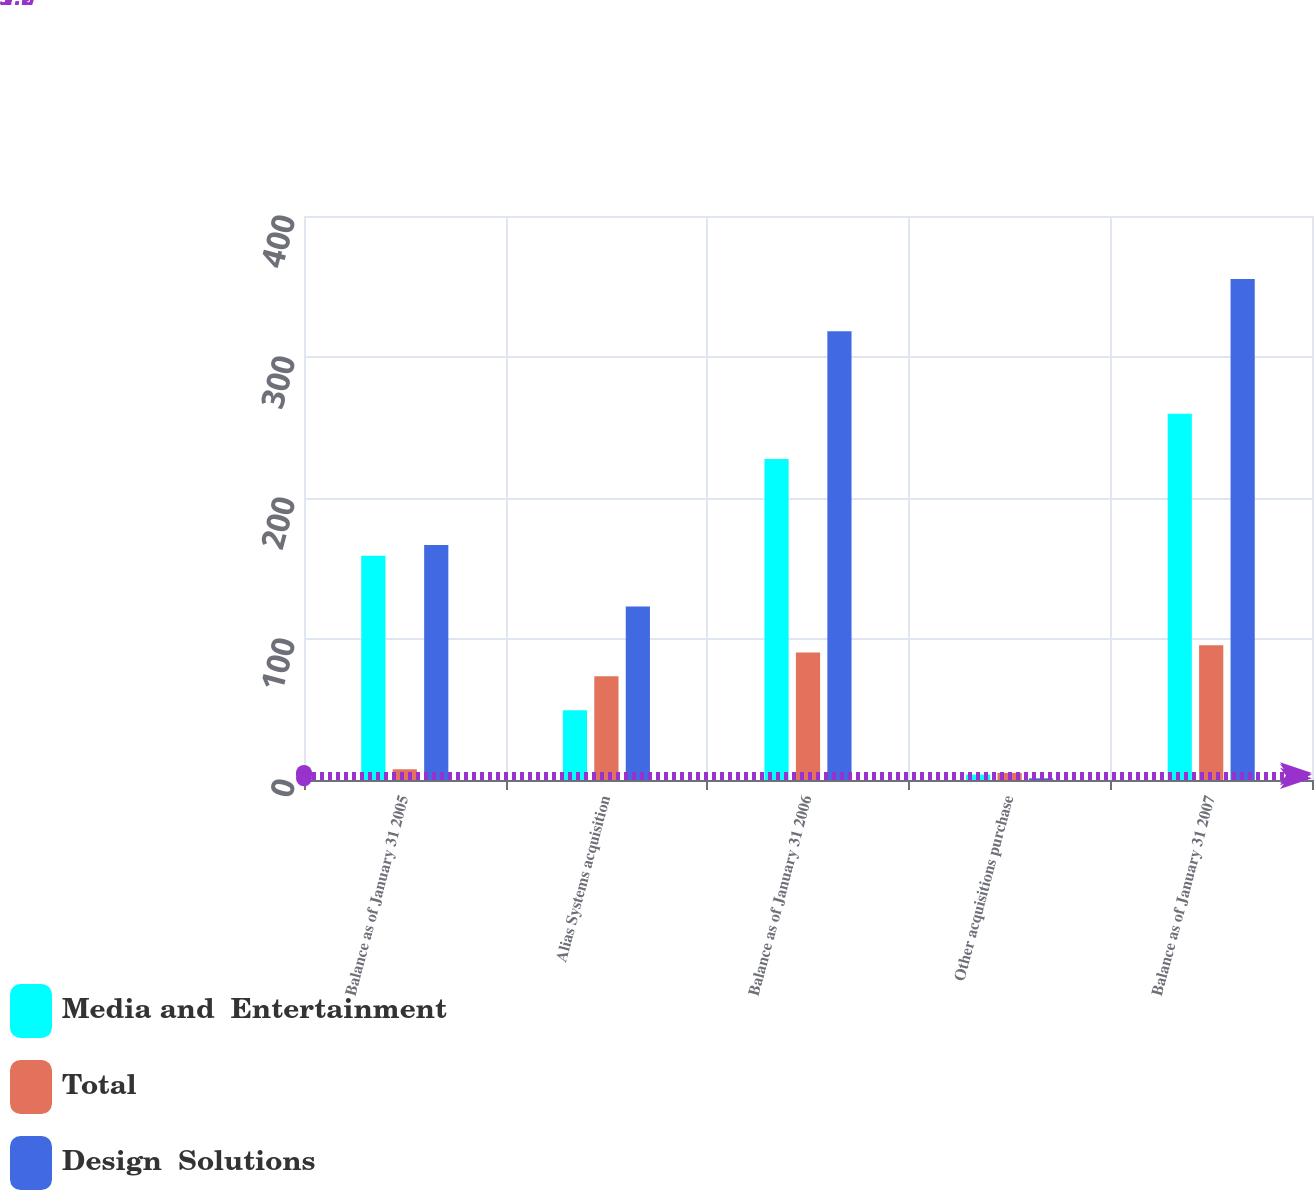<chart> <loc_0><loc_0><loc_500><loc_500><stacked_bar_chart><ecel><fcel>Balance as of January 31 2005<fcel>Alias Systems acquisition<fcel>Balance as of January 31 2006<fcel>Other acquisitions purchase<fcel>Balance as of January 31 2007<nl><fcel>Media and  Entertainment<fcel>159<fcel>49.5<fcel>227.7<fcel>3.8<fcel>259.8<nl><fcel>Total<fcel>7.6<fcel>73.5<fcel>90.5<fcel>5<fcel>95.5<nl><fcel>Design  Solutions<fcel>166.6<fcel>123<fcel>318.2<fcel>1.2<fcel>355.3<nl></chart> 